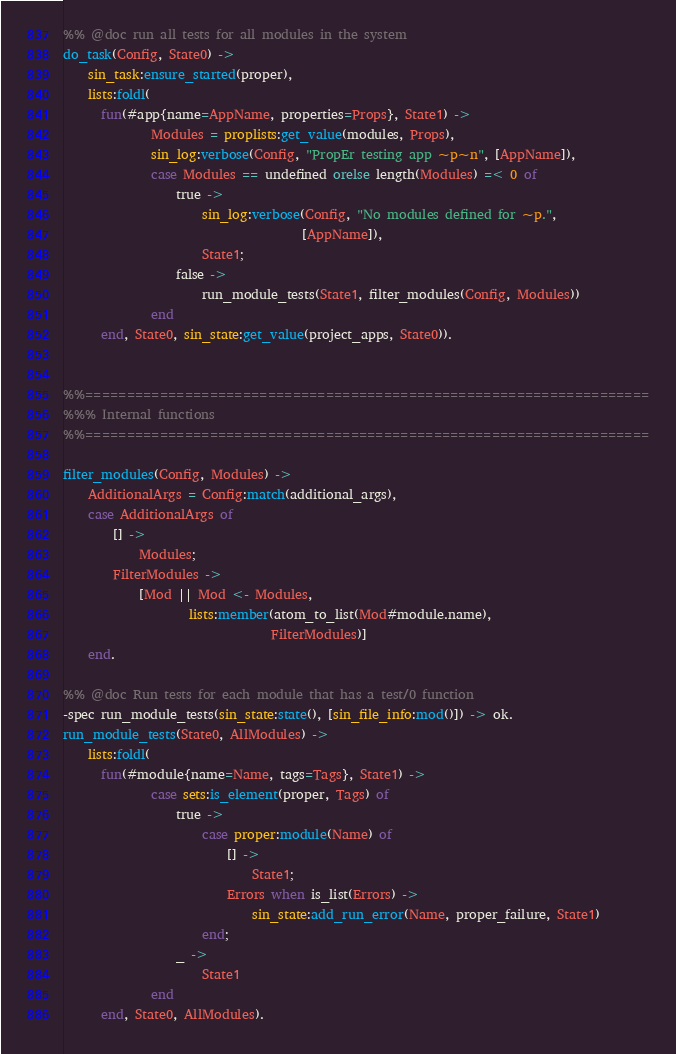Convert code to text. <code><loc_0><loc_0><loc_500><loc_500><_Erlang_>
%% @doc run all tests for all modules in the system
do_task(Config, State0) ->
    sin_task:ensure_started(proper),
    lists:foldl(
      fun(#app{name=AppName, properties=Props}, State1) ->
              Modules = proplists:get_value(modules, Props),
              sin_log:verbose(Config, "PropEr testing app ~p~n", [AppName]),
              case Modules == undefined orelse length(Modules) =< 0 of
                  true ->
                      sin_log:verbose(Config, "No modules defined for ~p.",
                                      [AppName]),
                      State1;
                  false ->
                      run_module_tests(State1, filter_modules(Config, Modules))
              end
      end, State0, sin_state:get_value(project_apps, State0)).


%%====================================================================
%%% Internal functions
%%====================================================================

filter_modules(Config, Modules) ->
    AdditionalArgs = Config:match(additional_args),
    case AdditionalArgs of
        [] ->
            Modules;
        FilterModules ->
            [Mod || Mod <- Modules,
                    lists:member(atom_to_list(Mod#module.name),
                                 FilterModules)]
    end.

%% @doc Run tests for each module that has a test/0 function
-spec run_module_tests(sin_state:state(), [sin_file_info:mod()]) -> ok.
run_module_tests(State0, AllModules) ->
    lists:foldl(
      fun(#module{name=Name, tags=Tags}, State1) ->
              case sets:is_element(proper, Tags) of
                  true ->
                      case proper:module(Name) of
                          [] ->
                              State1;
                          Errors when is_list(Errors) ->
                              sin_state:add_run_error(Name, proper_failure, State1)
                      end;
                  _ ->
                      State1
              end
      end, State0, AllModules).
</code> 